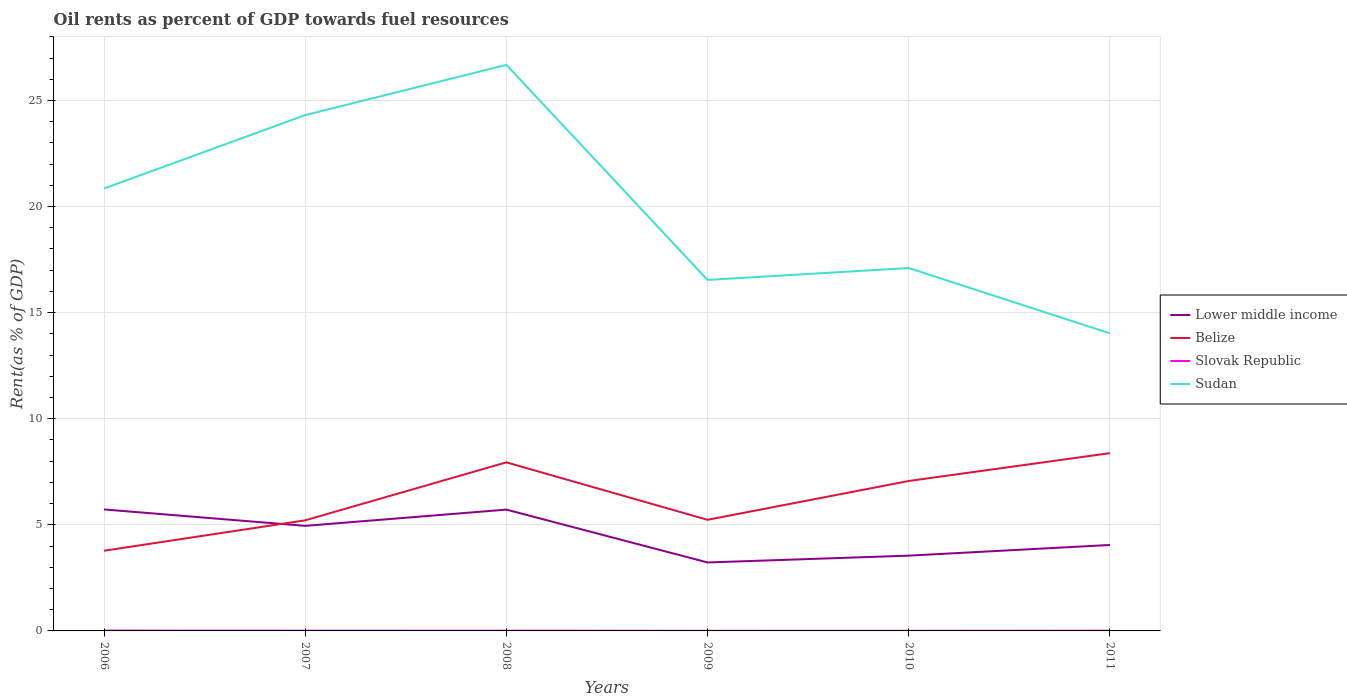Does the line corresponding to Belize intersect with the line corresponding to Slovak Republic?
Keep it short and to the point. No. Across all years, what is the maximum oil rent in Slovak Republic?
Ensure brevity in your answer.  0.01. What is the total oil rent in Slovak Republic in the graph?
Make the answer very short. 0. What is the difference between the highest and the second highest oil rent in Slovak Republic?
Your response must be concise. 0.01. Is the oil rent in Belize strictly greater than the oil rent in Sudan over the years?
Make the answer very short. Yes. How many lines are there?
Offer a terse response. 4. Does the graph contain grids?
Your answer should be very brief. Yes. Where does the legend appear in the graph?
Your answer should be very brief. Center right. How many legend labels are there?
Your answer should be compact. 4. How are the legend labels stacked?
Provide a short and direct response. Vertical. What is the title of the graph?
Your answer should be compact. Oil rents as percent of GDP towards fuel resources. Does "Morocco" appear as one of the legend labels in the graph?
Provide a short and direct response. No. What is the label or title of the X-axis?
Offer a terse response. Years. What is the label or title of the Y-axis?
Offer a very short reply. Rent(as % of GDP). What is the Rent(as % of GDP) in Lower middle income in 2006?
Make the answer very short. 5.73. What is the Rent(as % of GDP) in Belize in 2006?
Give a very brief answer. 3.78. What is the Rent(as % of GDP) of Slovak Republic in 2006?
Your answer should be compact. 0.02. What is the Rent(as % of GDP) of Sudan in 2006?
Your answer should be very brief. 20.85. What is the Rent(as % of GDP) of Lower middle income in 2007?
Provide a succinct answer. 4.95. What is the Rent(as % of GDP) in Belize in 2007?
Provide a short and direct response. 5.21. What is the Rent(as % of GDP) of Slovak Republic in 2007?
Your answer should be very brief. 0.01. What is the Rent(as % of GDP) in Sudan in 2007?
Ensure brevity in your answer.  24.31. What is the Rent(as % of GDP) in Lower middle income in 2008?
Your answer should be very brief. 5.72. What is the Rent(as % of GDP) in Belize in 2008?
Provide a short and direct response. 7.94. What is the Rent(as % of GDP) of Slovak Republic in 2008?
Your response must be concise. 0.01. What is the Rent(as % of GDP) in Sudan in 2008?
Give a very brief answer. 26.68. What is the Rent(as % of GDP) in Lower middle income in 2009?
Keep it short and to the point. 3.23. What is the Rent(as % of GDP) in Belize in 2009?
Your answer should be very brief. 5.24. What is the Rent(as % of GDP) in Slovak Republic in 2009?
Offer a very short reply. 0.01. What is the Rent(as % of GDP) in Sudan in 2009?
Make the answer very short. 16.54. What is the Rent(as % of GDP) in Lower middle income in 2010?
Make the answer very short. 3.55. What is the Rent(as % of GDP) in Belize in 2010?
Your answer should be very brief. 7.07. What is the Rent(as % of GDP) of Slovak Republic in 2010?
Keep it short and to the point. 0.01. What is the Rent(as % of GDP) of Sudan in 2010?
Make the answer very short. 17.1. What is the Rent(as % of GDP) in Lower middle income in 2011?
Your answer should be compact. 4.05. What is the Rent(as % of GDP) of Belize in 2011?
Your response must be concise. 8.38. What is the Rent(as % of GDP) of Slovak Republic in 2011?
Make the answer very short. 0.01. What is the Rent(as % of GDP) of Sudan in 2011?
Provide a succinct answer. 14.02. Across all years, what is the maximum Rent(as % of GDP) of Lower middle income?
Offer a very short reply. 5.73. Across all years, what is the maximum Rent(as % of GDP) in Belize?
Your answer should be very brief. 8.38. Across all years, what is the maximum Rent(as % of GDP) in Slovak Republic?
Make the answer very short. 0.02. Across all years, what is the maximum Rent(as % of GDP) in Sudan?
Your answer should be compact. 26.68. Across all years, what is the minimum Rent(as % of GDP) in Lower middle income?
Provide a short and direct response. 3.23. Across all years, what is the minimum Rent(as % of GDP) in Belize?
Offer a very short reply. 3.78. Across all years, what is the minimum Rent(as % of GDP) of Slovak Republic?
Give a very brief answer. 0.01. Across all years, what is the minimum Rent(as % of GDP) of Sudan?
Make the answer very short. 14.02. What is the total Rent(as % of GDP) in Lower middle income in the graph?
Provide a short and direct response. 27.22. What is the total Rent(as % of GDP) of Belize in the graph?
Offer a very short reply. 37.62. What is the total Rent(as % of GDP) in Slovak Republic in the graph?
Ensure brevity in your answer.  0.06. What is the total Rent(as % of GDP) of Sudan in the graph?
Make the answer very short. 119.51. What is the difference between the Rent(as % of GDP) of Lower middle income in 2006 and that in 2007?
Give a very brief answer. 0.77. What is the difference between the Rent(as % of GDP) in Belize in 2006 and that in 2007?
Offer a terse response. -1.43. What is the difference between the Rent(as % of GDP) in Slovak Republic in 2006 and that in 2007?
Make the answer very short. 0. What is the difference between the Rent(as % of GDP) of Sudan in 2006 and that in 2007?
Provide a succinct answer. -3.46. What is the difference between the Rent(as % of GDP) of Lower middle income in 2006 and that in 2008?
Keep it short and to the point. 0.01. What is the difference between the Rent(as % of GDP) of Belize in 2006 and that in 2008?
Your answer should be compact. -4.17. What is the difference between the Rent(as % of GDP) of Slovak Republic in 2006 and that in 2008?
Provide a succinct answer. 0.01. What is the difference between the Rent(as % of GDP) of Sudan in 2006 and that in 2008?
Your answer should be very brief. -5.83. What is the difference between the Rent(as % of GDP) in Lower middle income in 2006 and that in 2009?
Make the answer very short. 2.5. What is the difference between the Rent(as % of GDP) of Belize in 2006 and that in 2009?
Your response must be concise. -1.46. What is the difference between the Rent(as % of GDP) in Slovak Republic in 2006 and that in 2009?
Provide a succinct answer. 0.01. What is the difference between the Rent(as % of GDP) in Sudan in 2006 and that in 2009?
Provide a succinct answer. 4.31. What is the difference between the Rent(as % of GDP) of Lower middle income in 2006 and that in 2010?
Provide a succinct answer. 2.18. What is the difference between the Rent(as % of GDP) of Belize in 2006 and that in 2010?
Your response must be concise. -3.29. What is the difference between the Rent(as % of GDP) in Slovak Republic in 2006 and that in 2010?
Make the answer very short. 0.01. What is the difference between the Rent(as % of GDP) in Sudan in 2006 and that in 2010?
Offer a terse response. 3.75. What is the difference between the Rent(as % of GDP) of Lower middle income in 2006 and that in 2011?
Your answer should be very brief. 1.67. What is the difference between the Rent(as % of GDP) of Belize in 2006 and that in 2011?
Your answer should be very brief. -4.6. What is the difference between the Rent(as % of GDP) in Slovak Republic in 2006 and that in 2011?
Keep it short and to the point. 0.01. What is the difference between the Rent(as % of GDP) in Sudan in 2006 and that in 2011?
Your answer should be very brief. 6.83. What is the difference between the Rent(as % of GDP) of Lower middle income in 2007 and that in 2008?
Provide a short and direct response. -0.77. What is the difference between the Rent(as % of GDP) in Belize in 2007 and that in 2008?
Give a very brief answer. -2.73. What is the difference between the Rent(as % of GDP) in Slovak Republic in 2007 and that in 2008?
Ensure brevity in your answer.  0. What is the difference between the Rent(as % of GDP) of Sudan in 2007 and that in 2008?
Offer a terse response. -2.37. What is the difference between the Rent(as % of GDP) in Lower middle income in 2007 and that in 2009?
Make the answer very short. 1.73. What is the difference between the Rent(as % of GDP) in Belize in 2007 and that in 2009?
Your response must be concise. -0.03. What is the difference between the Rent(as % of GDP) of Slovak Republic in 2007 and that in 2009?
Make the answer very short. 0.01. What is the difference between the Rent(as % of GDP) of Sudan in 2007 and that in 2009?
Ensure brevity in your answer.  7.77. What is the difference between the Rent(as % of GDP) of Lower middle income in 2007 and that in 2010?
Your answer should be compact. 1.4. What is the difference between the Rent(as % of GDP) of Belize in 2007 and that in 2010?
Offer a very short reply. -1.85. What is the difference between the Rent(as % of GDP) of Slovak Republic in 2007 and that in 2010?
Your response must be concise. 0. What is the difference between the Rent(as % of GDP) in Sudan in 2007 and that in 2010?
Provide a short and direct response. 7.21. What is the difference between the Rent(as % of GDP) of Lower middle income in 2007 and that in 2011?
Make the answer very short. 0.9. What is the difference between the Rent(as % of GDP) in Belize in 2007 and that in 2011?
Offer a terse response. -3.17. What is the difference between the Rent(as % of GDP) of Slovak Republic in 2007 and that in 2011?
Offer a very short reply. 0. What is the difference between the Rent(as % of GDP) of Sudan in 2007 and that in 2011?
Your answer should be very brief. 10.29. What is the difference between the Rent(as % of GDP) of Lower middle income in 2008 and that in 2009?
Make the answer very short. 2.49. What is the difference between the Rent(as % of GDP) of Belize in 2008 and that in 2009?
Make the answer very short. 2.71. What is the difference between the Rent(as % of GDP) of Slovak Republic in 2008 and that in 2009?
Offer a very short reply. 0.01. What is the difference between the Rent(as % of GDP) of Sudan in 2008 and that in 2009?
Offer a very short reply. 10.14. What is the difference between the Rent(as % of GDP) of Lower middle income in 2008 and that in 2010?
Give a very brief answer. 2.17. What is the difference between the Rent(as % of GDP) of Belize in 2008 and that in 2010?
Provide a short and direct response. 0.88. What is the difference between the Rent(as % of GDP) in Slovak Republic in 2008 and that in 2010?
Your answer should be compact. 0. What is the difference between the Rent(as % of GDP) in Sudan in 2008 and that in 2010?
Offer a very short reply. 9.57. What is the difference between the Rent(as % of GDP) of Lower middle income in 2008 and that in 2011?
Make the answer very short. 1.67. What is the difference between the Rent(as % of GDP) in Belize in 2008 and that in 2011?
Offer a very short reply. -0.43. What is the difference between the Rent(as % of GDP) in Slovak Republic in 2008 and that in 2011?
Provide a short and direct response. 0. What is the difference between the Rent(as % of GDP) of Sudan in 2008 and that in 2011?
Provide a succinct answer. 12.65. What is the difference between the Rent(as % of GDP) in Lower middle income in 2009 and that in 2010?
Give a very brief answer. -0.32. What is the difference between the Rent(as % of GDP) in Belize in 2009 and that in 2010?
Keep it short and to the point. -1.83. What is the difference between the Rent(as % of GDP) of Slovak Republic in 2009 and that in 2010?
Give a very brief answer. -0. What is the difference between the Rent(as % of GDP) of Sudan in 2009 and that in 2010?
Your response must be concise. -0.56. What is the difference between the Rent(as % of GDP) of Lower middle income in 2009 and that in 2011?
Provide a short and direct response. -0.82. What is the difference between the Rent(as % of GDP) of Belize in 2009 and that in 2011?
Make the answer very short. -3.14. What is the difference between the Rent(as % of GDP) of Slovak Republic in 2009 and that in 2011?
Your response must be concise. -0. What is the difference between the Rent(as % of GDP) of Sudan in 2009 and that in 2011?
Give a very brief answer. 2.52. What is the difference between the Rent(as % of GDP) of Lower middle income in 2010 and that in 2011?
Offer a terse response. -0.5. What is the difference between the Rent(as % of GDP) of Belize in 2010 and that in 2011?
Provide a short and direct response. -1.31. What is the difference between the Rent(as % of GDP) in Slovak Republic in 2010 and that in 2011?
Offer a terse response. -0. What is the difference between the Rent(as % of GDP) of Sudan in 2010 and that in 2011?
Your answer should be compact. 3.08. What is the difference between the Rent(as % of GDP) of Lower middle income in 2006 and the Rent(as % of GDP) of Belize in 2007?
Give a very brief answer. 0.51. What is the difference between the Rent(as % of GDP) in Lower middle income in 2006 and the Rent(as % of GDP) in Slovak Republic in 2007?
Offer a very short reply. 5.71. What is the difference between the Rent(as % of GDP) of Lower middle income in 2006 and the Rent(as % of GDP) of Sudan in 2007?
Offer a terse response. -18.59. What is the difference between the Rent(as % of GDP) of Belize in 2006 and the Rent(as % of GDP) of Slovak Republic in 2007?
Offer a very short reply. 3.77. What is the difference between the Rent(as % of GDP) in Belize in 2006 and the Rent(as % of GDP) in Sudan in 2007?
Give a very brief answer. -20.53. What is the difference between the Rent(as % of GDP) in Slovak Republic in 2006 and the Rent(as % of GDP) in Sudan in 2007?
Ensure brevity in your answer.  -24.29. What is the difference between the Rent(as % of GDP) of Lower middle income in 2006 and the Rent(as % of GDP) of Belize in 2008?
Your answer should be very brief. -2.22. What is the difference between the Rent(as % of GDP) in Lower middle income in 2006 and the Rent(as % of GDP) in Slovak Republic in 2008?
Give a very brief answer. 5.71. What is the difference between the Rent(as % of GDP) in Lower middle income in 2006 and the Rent(as % of GDP) in Sudan in 2008?
Ensure brevity in your answer.  -20.95. What is the difference between the Rent(as % of GDP) in Belize in 2006 and the Rent(as % of GDP) in Slovak Republic in 2008?
Offer a terse response. 3.77. What is the difference between the Rent(as % of GDP) in Belize in 2006 and the Rent(as % of GDP) in Sudan in 2008?
Give a very brief answer. -22.9. What is the difference between the Rent(as % of GDP) of Slovak Republic in 2006 and the Rent(as % of GDP) of Sudan in 2008?
Your answer should be compact. -26.66. What is the difference between the Rent(as % of GDP) of Lower middle income in 2006 and the Rent(as % of GDP) of Belize in 2009?
Provide a succinct answer. 0.49. What is the difference between the Rent(as % of GDP) in Lower middle income in 2006 and the Rent(as % of GDP) in Slovak Republic in 2009?
Offer a terse response. 5.72. What is the difference between the Rent(as % of GDP) of Lower middle income in 2006 and the Rent(as % of GDP) of Sudan in 2009?
Give a very brief answer. -10.82. What is the difference between the Rent(as % of GDP) in Belize in 2006 and the Rent(as % of GDP) in Slovak Republic in 2009?
Keep it short and to the point. 3.77. What is the difference between the Rent(as % of GDP) of Belize in 2006 and the Rent(as % of GDP) of Sudan in 2009?
Keep it short and to the point. -12.76. What is the difference between the Rent(as % of GDP) in Slovak Republic in 2006 and the Rent(as % of GDP) in Sudan in 2009?
Keep it short and to the point. -16.53. What is the difference between the Rent(as % of GDP) in Lower middle income in 2006 and the Rent(as % of GDP) in Belize in 2010?
Keep it short and to the point. -1.34. What is the difference between the Rent(as % of GDP) of Lower middle income in 2006 and the Rent(as % of GDP) of Slovak Republic in 2010?
Make the answer very short. 5.72. What is the difference between the Rent(as % of GDP) of Lower middle income in 2006 and the Rent(as % of GDP) of Sudan in 2010?
Your answer should be very brief. -11.38. What is the difference between the Rent(as % of GDP) of Belize in 2006 and the Rent(as % of GDP) of Slovak Republic in 2010?
Your answer should be compact. 3.77. What is the difference between the Rent(as % of GDP) of Belize in 2006 and the Rent(as % of GDP) of Sudan in 2010?
Keep it short and to the point. -13.32. What is the difference between the Rent(as % of GDP) of Slovak Republic in 2006 and the Rent(as % of GDP) of Sudan in 2010?
Your answer should be compact. -17.09. What is the difference between the Rent(as % of GDP) in Lower middle income in 2006 and the Rent(as % of GDP) in Belize in 2011?
Keep it short and to the point. -2.65. What is the difference between the Rent(as % of GDP) of Lower middle income in 2006 and the Rent(as % of GDP) of Slovak Republic in 2011?
Ensure brevity in your answer.  5.72. What is the difference between the Rent(as % of GDP) of Lower middle income in 2006 and the Rent(as % of GDP) of Sudan in 2011?
Your answer should be compact. -8.3. What is the difference between the Rent(as % of GDP) in Belize in 2006 and the Rent(as % of GDP) in Slovak Republic in 2011?
Ensure brevity in your answer.  3.77. What is the difference between the Rent(as % of GDP) in Belize in 2006 and the Rent(as % of GDP) in Sudan in 2011?
Your response must be concise. -10.24. What is the difference between the Rent(as % of GDP) in Slovak Republic in 2006 and the Rent(as % of GDP) in Sudan in 2011?
Ensure brevity in your answer.  -14.01. What is the difference between the Rent(as % of GDP) of Lower middle income in 2007 and the Rent(as % of GDP) of Belize in 2008?
Make the answer very short. -2.99. What is the difference between the Rent(as % of GDP) of Lower middle income in 2007 and the Rent(as % of GDP) of Slovak Republic in 2008?
Ensure brevity in your answer.  4.94. What is the difference between the Rent(as % of GDP) in Lower middle income in 2007 and the Rent(as % of GDP) in Sudan in 2008?
Your response must be concise. -21.73. What is the difference between the Rent(as % of GDP) of Belize in 2007 and the Rent(as % of GDP) of Slovak Republic in 2008?
Your answer should be very brief. 5.2. What is the difference between the Rent(as % of GDP) in Belize in 2007 and the Rent(as % of GDP) in Sudan in 2008?
Offer a terse response. -21.47. What is the difference between the Rent(as % of GDP) in Slovak Republic in 2007 and the Rent(as % of GDP) in Sudan in 2008?
Offer a very short reply. -26.67. What is the difference between the Rent(as % of GDP) of Lower middle income in 2007 and the Rent(as % of GDP) of Belize in 2009?
Ensure brevity in your answer.  -0.29. What is the difference between the Rent(as % of GDP) in Lower middle income in 2007 and the Rent(as % of GDP) in Slovak Republic in 2009?
Ensure brevity in your answer.  4.95. What is the difference between the Rent(as % of GDP) of Lower middle income in 2007 and the Rent(as % of GDP) of Sudan in 2009?
Provide a short and direct response. -11.59. What is the difference between the Rent(as % of GDP) in Belize in 2007 and the Rent(as % of GDP) in Slovak Republic in 2009?
Give a very brief answer. 5.21. What is the difference between the Rent(as % of GDP) in Belize in 2007 and the Rent(as % of GDP) in Sudan in 2009?
Your answer should be very brief. -11.33. What is the difference between the Rent(as % of GDP) of Slovak Republic in 2007 and the Rent(as % of GDP) of Sudan in 2009?
Provide a succinct answer. -16.53. What is the difference between the Rent(as % of GDP) in Lower middle income in 2007 and the Rent(as % of GDP) in Belize in 2010?
Give a very brief answer. -2.12. What is the difference between the Rent(as % of GDP) in Lower middle income in 2007 and the Rent(as % of GDP) in Slovak Republic in 2010?
Your answer should be very brief. 4.94. What is the difference between the Rent(as % of GDP) of Lower middle income in 2007 and the Rent(as % of GDP) of Sudan in 2010?
Give a very brief answer. -12.15. What is the difference between the Rent(as % of GDP) of Belize in 2007 and the Rent(as % of GDP) of Slovak Republic in 2010?
Make the answer very short. 5.21. What is the difference between the Rent(as % of GDP) of Belize in 2007 and the Rent(as % of GDP) of Sudan in 2010?
Ensure brevity in your answer.  -11.89. What is the difference between the Rent(as % of GDP) of Slovak Republic in 2007 and the Rent(as % of GDP) of Sudan in 2010?
Give a very brief answer. -17.09. What is the difference between the Rent(as % of GDP) in Lower middle income in 2007 and the Rent(as % of GDP) in Belize in 2011?
Provide a short and direct response. -3.43. What is the difference between the Rent(as % of GDP) in Lower middle income in 2007 and the Rent(as % of GDP) in Slovak Republic in 2011?
Offer a very short reply. 4.94. What is the difference between the Rent(as % of GDP) of Lower middle income in 2007 and the Rent(as % of GDP) of Sudan in 2011?
Offer a terse response. -9.07. What is the difference between the Rent(as % of GDP) of Belize in 2007 and the Rent(as % of GDP) of Slovak Republic in 2011?
Provide a short and direct response. 5.2. What is the difference between the Rent(as % of GDP) of Belize in 2007 and the Rent(as % of GDP) of Sudan in 2011?
Offer a very short reply. -8.81. What is the difference between the Rent(as % of GDP) in Slovak Republic in 2007 and the Rent(as % of GDP) in Sudan in 2011?
Ensure brevity in your answer.  -14.01. What is the difference between the Rent(as % of GDP) in Lower middle income in 2008 and the Rent(as % of GDP) in Belize in 2009?
Give a very brief answer. 0.48. What is the difference between the Rent(as % of GDP) in Lower middle income in 2008 and the Rent(as % of GDP) in Slovak Republic in 2009?
Ensure brevity in your answer.  5.71. What is the difference between the Rent(as % of GDP) of Lower middle income in 2008 and the Rent(as % of GDP) of Sudan in 2009?
Offer a terse response. -10.82. What is the difference between the Rent(as % of GDP) in Belize in 2008 and the Rent(as % of GDP) in Slovak Republic in 2009?
Keep it short and to the point. 7.94. What is the difference between the Rent(as % of GDP) in Belize in 2008 and the Rent(as % of GDP) in Sudan in 2009?
Your answer should be very brief. -8.6. What is the difference between the Rent(as % of GDP) of Slovak Republic in 2008 and the Rent(as % of GDP) of Sudan in 2009?
Your response must be concise. -16.53. What is the difference between the Rent(as % of GDP) in Lower middle income in 2008 and the Rent(as % of GDP) in Belize in 2010?
Ensure brevity in your answer.  -1.35. What is the difference between the Rent(as % of GDP) of Lower middle income in 2008 and the Rent(as % of GDP) of Slovak Republic in 2010?
Offer a very short reply. 5.71. What is the difference between the Rent(as % of GDP) of Lower middle income in 2008 and the Rent(as % of GDP) of Sudan in 2010?
Ensure brevity in your answer.  -11.39. What is the difference between the Rent(as % of GDP) of Belize in 2008 and the Rent(as % of GDP) of Slovak Republic in 2010?
Provide a succinct answer. 7.94. What is the difference between the Rent(as % of GDP) of Belize in 2008 and the Rent(as % of GDP) of Sudan in 2010?
Your response must be concise. -9.16. What is the difference between the Rent(as % of GDP) in Slovak Republic in 2008 and the Rent(as % of GDP) in Sudan in 2010?
Make the answer very short. -17.09. What is the difference between the Rent(as % of GDP) of Lower middle income in 2008 and the Rent(as % of GDP) of Belize in 2011?
Offer a very short reply. -2.66. What is the difference between the Rent(as % of GDP) of Lower middle income in 2008 and the Rent(as % of GDP) of Slovak Republic in 2011?
Offer a very short reply. 5.71. What is the difference between the Rent(as % of GDP) in Lower middle income in 2008 and the Rent(as % of GDP) in Sudan in 2011?
Keep it short and to the point. -8.31. What is the difference between the Rent(as % of GDP) in Belize in 2008 and the Rent(as % of GDP) in Slovak Republic in 2011?
Your answer should be very brief. 7.94. What is the difference between the Rent(as % of GDP) in Belize in 2008 and the Rent(as % of GDP) in Sudan in 2011?
Keep it short and to the point. -6.08. What is the difference between the Rent(as % of GDP) in Slovak Republic in 2008 and the Rent(as % of GDP) in Sudan in 2011?
Your answer should be very brief. -14.01. What is the difference between the Rent(as % of GDP) of Lower middle income in 2009 and the Rent(as % of GDP) of Belize in 2010?
Give a very brief answer. -3.84. What is the difference between the Rent(as % of GDP) of Lower middle income in 2009 and the Rent(as % of GDP) of Slovak Republic in 2010?
Offer a terse response. 3.22. What is the difference between the Rent(as % of GDP) of Lower middle income in 2009 and the Rent(as % of GDP) of Sudan in 2010?
Make the answer very short. -13.88. What is the difference between the Rent(as % of GDP) of Belize in 2009 and the Rent(as % of GDP) of Slovak Republic in 2010?
Give a very brief answer. 5.23. What is the difference between the Rent(as % of GDP) in Belize in 2009 and the Rent(as % of GDP) in Sudan in 2010?
Your response must be concise. -11.87. What is the difference between the Rent(as % of GDP) in Slovak Republic in 2009 and the Rent(as % of GDP) in Sudan in 2010?
Give a very brief answer. -17.1. What is the difference between the Rent(as % of GDP) in Lower middle income in 2009 and the Rent(as % of GDP) in Belize in 2011?
Give a very brief answer. -5.15. What is the difference between the Rent(as % of GDP) of Lower middle income in 2009 and the Rent(as % of GDP) of Slovak Republic in 2011?
Provide a short and direct response. 3.22. What is the difference between the Rent(as % of GDP) of Lower middle income in 2009 and the Rent(as % of GDP) of Sudan in 2011?
Give a very brief answer. -10.8. What is the difference between the Rent(as % of GDP) in Belize in 2009 and the Rent(as % of GDP) in Slovak Republic in 2011?
Provide a short and direct response. 5.23. What is the difference between the Rent(as % of GDP) in Belize in 2009 and the Rent(as % of GDP) in Sudan in 2011?
Offer a very short reply. -8.79. What is the difference between the Rent(as % of GDP) in Slovak Republic in 2009 and the Rent(as % of GDP) in Sudan in 2011?
Make the answer very short. -14.02. What is the difference between the Rent(as % of GDP) in Lower middle income in 2010 and the Rent(as % of GDP) in Belize in 2011?
Offer a very short reply. -4.83. What is the difference between the Rent(as % of GDP) in Lower middle income in 2010 and the Rent(as % of GDP) in Slovak Republic in 2011?
Keep it short and to the point. 3.54. What is the difference between the Rent(as % of GDP) of Lower middle income in 2010 and the Rent(as % of GDP) of Sudan in 2011?
Offer a terse response. -10.48. What is the difference between the Rent(as % of GDP) of Belize in 2010 and the Rent(as % of GDP) of Slovak Republic in 2011?
Your answer should be compact. 7.06. What is the difference between the Rent(as % of GDP) of Belize in 2010 and the Rent(as % of GDP) of Sudan in 2011?
Your response must be concise. -6.96. What is the difference between the Rent(as % of GDP) of Slovak Republic in 2010 and the Rent(as % of GDP) of Sudan in 2011?
Provide a short and direct response. -14.02. What is the average Rent(as % of GDP) in Lower middle income per year?
Provide a succinct answer. 4.54. What is the average Rent(as % of GDP) of Belize per year?
Offer a very short reply. 6.27. What is the average Rent(as % of GDP) of Slovak Republic per year?
Give a very brief answer. 0.01. What is the average Rent(as % of GDP) of Sudan per year?
Your response must be concise. 19.92. In the year 2006, what is the difference between the Rent(as % of GDP) of Lower middle income and Rent(as % of GDP) of Belize?
Give a very brief answer. 1.95. In the year 2006, what is the difference between the Rent(as % of GDP) in Lower middle income and Rent(as % of GDP) in Slovak Republic?
Provide a short and direct response. 5.71. In the year 2006, what is the difference between the Rent(as % of GDP) in Lower middle income and Rent(as % of GDP) in Sudan?
Offer a terse response. -15.12. In the year 2006, what is the difference between the Rent(as % of GDP) of Belize and Rent(as % of GDP) of Slovak Republic?
Provide a succinct answer. 3.76. In the year 2006, what is the difference between the Rent(as % of GDP) in Belize and Rent(as % of GDP) in Sudan?
Ensure brevity in your answer.  -17.07. In the year 2006, what is the difference between the Rent(as % of GDP) of Slovak Republic and Rent(as % of GDP) of Sudan?
Your answer should be compact. -20.83. In the year 2007, what is the difference between the Rent(as % of GDP) in Lower middle income and Rent(as % of GDP) in Belize?
Keep it short and to the point. -0.26. In the year 2007, what is the difference between the Rent(as % of GDP) of Lower middle income and Rent(as % of GDP) of Slovak Republic?
Provide a short and direct response. 4.94. In the year 2007, what is the difference between the Rent(as % of GDP) in Lower middle income and Rent(as % of GDP) in Sudan?
Give a very brief answer. -19.36. In the year 2007, what is the difference between the Rent(as % of GDP) in Belize and Rent(as % of GDP) in Slovak Republic?
Your answer should be very brief. 5.2. In the year 2007, what is the difference between the Rent(as % of GDP) of Belize and Rent(as % of GDP) of Sudan?
Provide a short and direct response. -19.1. In the year 2007, what is the difference between the Rent(as % of GDP) of Slovak Republic and Rent(as % of GDP) of Sudan?
Make the answer very short. -24.3. In the year 2008, what is the difference between the Rent(as % of GDP) of Lower middle income and Rent(as % of GDP) of Belize?
Offer a terse response. -2.23. In the year 2008, what is the difference between the Rent(as % of GDP) in Lower middle income and Rent(as % of GDP) in Slovak Republic?
Make the answer very short. 5.71. In the year 2008, what is the difference between the Rent(as % of GDP) in Lower middle income and Rent(as % of GDP) in Sudan?
Give a very brief answer. -20.96. In the year 2008, what is the difference between the Rent(as % of GDP) of Belize and Rent(as % of GDP) of Slovak Republic?
Ensure brevity in your answer.  7.93. In the year 2008, what is the difference between the Rent(as % of GDP) in Belize and Rent(as % of GDP) in Sudan?
Your answer should be compact. -18.73. In the year 2008, what is the difference between the Rent(as % of GDP) of Slovak Republic and Rent(as % of GDP) of Sudan?
Your answer should be very brief. -26.67. In the year 2009, what is the difference between the Rent(as % of GDP) in Lower middle income and Rent(as % of GDP) in Belize?
Make the answer very short. -2.01. In the year 2009, what is the difference between the Rent(as % of GDP) of Lower middle income and Rent(as % of GDP) of Slovak Republic?
Offer a very short reply. 3.22. In the year 2009, what is the difference between the Rent(as % of GDP) in Lower middle income and Rent(as % of GDP) in Sudan?
Offer a terse response. -13.32. In the year 2009, what is the difference between the Rent(as % of GDP) of Belize and Rent(as % of GDP) of Slovak Republic?
Provide a succinct answer. 5.23. In the year 2009, what is the difference between the Rent(as % of GDP) in Belize and Rent(as % of GDP) in Sudan?
Make the answer very short. -11.3. In the year 2009, what is the difference between the Rent(as % of GDP) in Slovak Republic and Rent(as % of GDP) in Sudan?
Make the answer very short. -16.54. In the year 2010, what is the difference between the Rent(as % of GDP) in Lower middle income and Rent(as % of GDP) in Belize?
Ensure brevity in your answer.  -3.52. In the year 2010, what is the difference between the Rent(as % of GDP) in Lower middle income and Rent(as % of GDP) in Slovak Republic?
Give a very brief answer. 3.54. In the year 2010, what is the difference between the Rent(as % of GDP) in Lower middle income and Rent(as % of GDP) in Sudan?
Your answer should be compact. -13.55. In the year 2010, what is the difference between the Rent(as % of GDP) of Belize and Rent(as % of GDP) of Slovak Republic?
Make the answer very short. 7.06. In the year 2010, what is the difference between the Rent(as % of GDP) in Belize and Rent(as % of GDP) in Sudan?
Give a very brief answer. -10.04. In the year 2010, what is the difference between the Rent(as % of GDP) of Slovak Republic and Rent(as % of GDP) of Sudan?
Make the answer very short. -17.1. In the year 2011, what is the difference between the Rent(as % of GDP) in Lower middle income and Rent(as % of GDP) in Belize?
Ensure brevity in your answer.  -4.33. In the year 2011, what is the difference between the Rent(as % of GDP) in Lower middle income and Rent(as % of GDP) in Slovak Republic?
Offer a very short reply. 4.04. In the year 2011, what is the difference between the Rent(as % of GDP) in Lower middle income and Rent(as % of GDP) in Sudan?
Keep it short and to the point. -9.97. In the year 2011, what is the difference between the Rent(as % of GDP) of Belize and Rent(as % of GDP) of Slovak Republic?
Your answer should be compact. 8.37. In the year 2011, what is the difference between the Rent(as % of GDP) in Belize and Rent(as % of GDP) in Sudan?
Make the answer very short. -5.65. In the year 2011, what is the difference between the Rent(as % of GDP) of Slovak Republic and Rent(as % of GDP) of Sudan?
Your answer should be very brief. -14.01. What is the ratio of the Rent(as % of GDP) in Lower middle income in 2006 to that in 2007?
Your answer should be very brief. 1.16. What is the ratio of the Rent(as % of GDP) in Belize in 2006 to that in 2007?
Your response must be concise. 0.73. What is the ratio of the Rent(as % of GDP) of Slovak Republic in 2006 to that in 2007?
Make the answer very short. 1.41. What is the ratio of the Rent(as % of GDP) in Sudan in 2006 to that in 2007?
Provide a succinct answer. 0.86. What is the ratio of the Rent(as % of GDP) in Belize in 2006 to that in 2008?
Provide a short and direct response. 0.48. What is the ratio of the Rent(as % of GDP) in Slovak Republic in 2006 to that in 2008?
Provide a short and direct response. 1.45. What is the ratio of the Rent(as % of GDP) in Sudan in 2006 to that in 2008?
Give a very brief answer. 0.78. What is the ratio of the Rent(as % of GDP) of Lower middle income in 2006 to that in 2009?
Your answer should be very brief. 1.77. What is the ratio of the Rent(as % of GDP) of Belize in 2006 to that in 2009?
Offer a terse response. 0.72. What is the ratio of the Rent(as % of GDP) of Slovak Republic in 2006 to that in 2009?
Your answer should be compact. 2.75. What is the ratio of the Rent(as % of GDP) of Sudan in 2006 to that in 2009?
Keep it short and to the point. 1.26. What is the ratio of the Rent(as % of GDP) in Lower middle income in 2006 to that in 2010?
Give a very brief answer. 1.61. What is the ratio of the Rent(as % of GDP) of Belize in 2006 to that in 2010?
Provide a succinct answer. 0.53. What is the ratio of the Rent(as % of GDP) in Slovak Republic in 2006 to that in 2010?
Ensure brevity in your answer.  2.4. What is the ratio of the Rent(as % of GDP) in Sudan in 2006 to that in 2010?
Your response must be concise. 1.22. What is the ratio of the Rent(as % of GDP) in Lower middle income in 2006 to that in 2011?
Ensure brevity in your answer.  1.41. What is the ratio of the Rent(as % of GDP) in Belize in 2006 to that in 2011?
Offer a terse response. 0.45. What is the ratio of the Rent(as % of GDP) of Slovak Republic in 2006 to that in 2011?
Make the answer very short. 1.7. What is the ratio of the Rent(as % of GDP) in Sudan in 2006 to that in 2011?
Offer a terse response. 1.49. What is the ratio of the Rent(as % of GDP) in Lower middle income in 2007 to that in 2008?
Give a very brief answer. 0.87. What is the ratio of the Rent(as % of GDP) in Belize in 2007 to that in 2008?
Keep it short and to the point. 0.66. What is the ratio of the Rent(as % of GDP) of Slovak Republic in 2007 to that in 2008?
Your answer should be compact. 1.03. What is the ratio of the Rent(as % of GDP) in Sudan in 2007 to that in 2008?
Your response must be concise. 0.91. What is the ratio of the Rent(as % of GDP) in Lower middle income in 2007 to that in 2009?
Offer a terse response. 1.53. What is the ratio of the Rent(as % of GDP) of Slovak Republic in 2007 to that in 2009?
Offer a terse response. 1.95. What is the ratio of the Rent(as % of GDP) in Sudan in 2007 to that in 2009?
Make the answer very short. 1.47. What is the ratio of the Rent(as % of GDP) in Lower middle income in 2007 to that in 2010?
Ensure brevity in your answer.  1.4. What is the ratio of the Rent(as % of GDP) of Belize in 2007 to that in 2010?
Offer a terse response. 0.74. What is the ratio of the Rent(as % of GDP) in Sudan in 2007 to that in 2010?
Ensure brevity in your answer.  1.42. What is the ratio of the Rent(as % of GDP) of Lower middle income in 2007 to that in 2011?
Keep it short and to the point. 1.22. What is the ratio of the Rent(as % of GDP) of Belize in 2007 to that in 2011?
Your answer should be compact. 0.62. What is the ratio of the Rent(as % of GDP) of Slovak Republic in 2007 to that in 2011?
Your response must be concise. 1.2. What is the ratio of the Rent(as % of GDP) of Sudan in 2007 to that in 2011?
Your response must be concise. 1.73. What is the ratio of the Rent(as % of GDP) in Lower middle income in 2008 to that in 2009?
Your answer should be very brief. 1.77. What is the ratio of the Rent(as % of GDP) of Belize in 2008 to that in 2009?
Make the answer very short. 1.52. What is the ratio of the Rent(as % of GDP) in Slovak Republic in 2008 to that in 2009?
Your answer should be compact. 1.89. What is the ratio of the Rent(as % of GDP) of Sudan in 2008 to that in 2009?
Your response must be concise. 1.61. What is the ratio of the Rent(as % of GDP) of Lower middle income in 2008 to that in 2010?
Your answer should be compact. 1.61. What is the ratio of the Rent(as % of GDP) in Belize in 2008 to that in 2010?
Offer a terse response. 1.12. What is the ratio of the Rent(as % of GDP) of Slovak Republic in 2008 to that in 2010?
Give a very brief answer. 1.65. What is the ratio of the Rent(as % of GDP) in Sudan in 2008 to that in 2010?
Keep it short and to the point. 1.56. What is the ratio of the Rent(as % of GDP) of Lower middle income in 2008 to that in 2011?
Your answer should be compact. 1.41. What is the ratio of the Rent(as % of GDP) of Belize in 2008 to that in 2011?
Offer a terse response. 0.95. What is the ratio of the Rent(as % of GDP) of Slovak Republic in 2008 to that in 2011?
Give a very brief answer. 1.17. What is the ratio of the Rent(as % of GDP) of Sudan in 2008 to that in 2011?
Give a very brief answer. 1.9. What is the ratio of the Rent(as % of GDP) in Lower middle income in 2009 to that in 2010?
Provide a short and direct response. 0.91. What is the ratio of the Rent(as % of GDP) of Belize in 2009 to that in 2010?
Give a very brief answer. 0.74. What is the ratio of the Rent(as % of GDP) in Slovak Republic in 2009 to that in 2010?
Provide a succinct answer. 0.87. What is the ratio of the Rent(as % of GDP) of Sudan in 2009 to that in 2010?
Provide a succinct answer. 0.97. What is the ratio of the Rent(as % of GDP) of Lower middle income in 2009 to that in 2011?
Keep it short and to the point. 0.8. What is the ratio of the Rent(as % of GDP) of Belize in 2009 to that in 2011?
Give a very brief answer. 0.63. What is the ratio of the Rent(as % of GDP) in Slovak Republic in 2009 to that in 2011?
Your response must be concise. 0.62. What is the ratio of the Rent(as % of GDP) of Sudan in 2009 to that in 2011?
Your response must be concise. 1.18. What is the ratio of the Rent(as % of GDP) of Lower middle income in 2010 to that in 2011?
Give a very brief answer. 0.88. What is the ratio of the Rent(as % of GDP) in Belize in 2010 to that in 2011?
Provide a short and direct response. 0.84. What is the ratio of the Rent(as % of GDP) in Slovak Republic in 2010 to that in 2011?
Provide a succinct answer. 0.71. What is the ratio of the Rent(as % of GDP) of Sudan in 2010 to that in 2011?
Offer a very short reply. 1.22. What is the difference between the highest and the second highest Rent(as % of GDP) of Lower middle income?
Give a very brief answer. 0.01. What is the difference between the highest and the second highest Rent(as % of GDP) in Belize?
Provide a succinct answer. 0.43. What is the difference between the highest and the second highest Rent(as % of GDP) in Slovak Republic?
Your response must be concise. 0. What is the difference between the highest and the second highest Rent(as % of GDP) in Sudan?
Provide a short and direct response. 2.37. What is the difference between the highest and the lowest Rent(as % of GDP) of Lower middle income?
Offer a terse response. 2.5. What is the difference between the highest and the lowest Rent(as % of GDP) of Belize?
Provide a succinct answer. 4.6. What is the difference between the highest and the lowest Rent(as % of GDP) in Slovak Republic?
Provide a succinct answer. 0.01. What is the difference between the highest and the lowest Rent(as % of GDP) of Sudan?
Offer a very short reply. 12.65. 